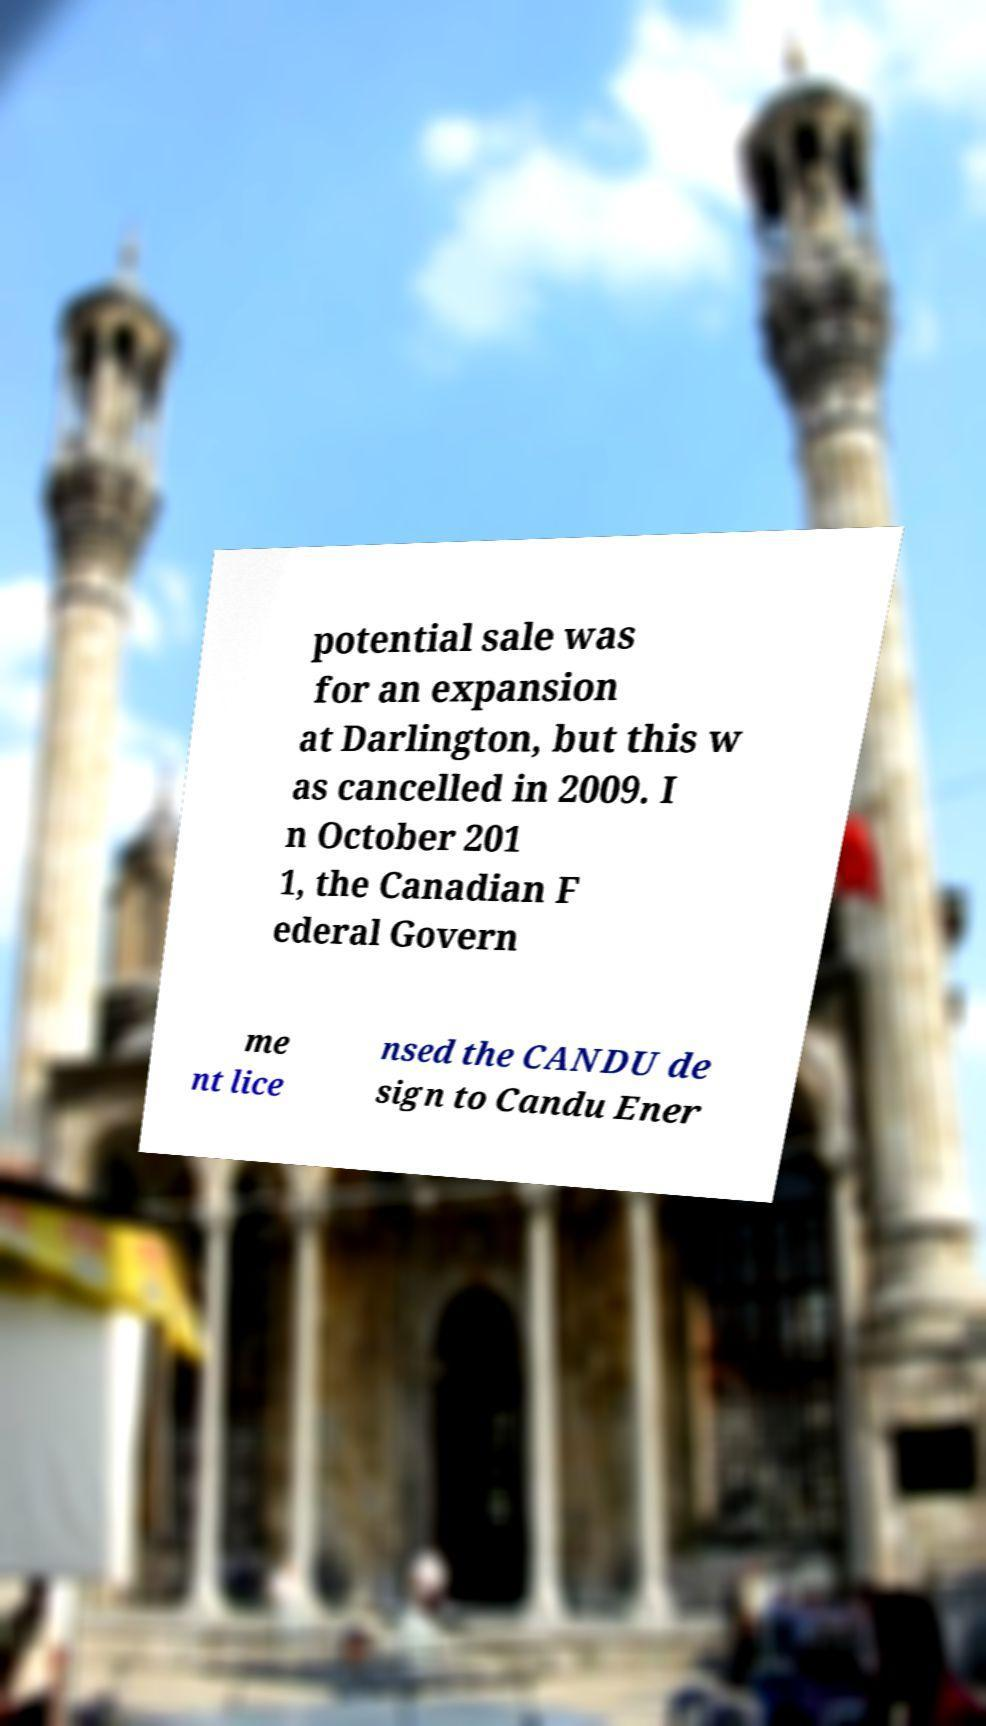I need the written content from this picture converted into text. Can you do that? potential sale was for an expansion at Darlington, but this w as cancelled in 2009. I n October 201 1, the Canadian F ederal Govern me nt lice nsed the CANDU de sign to Candu Ener 